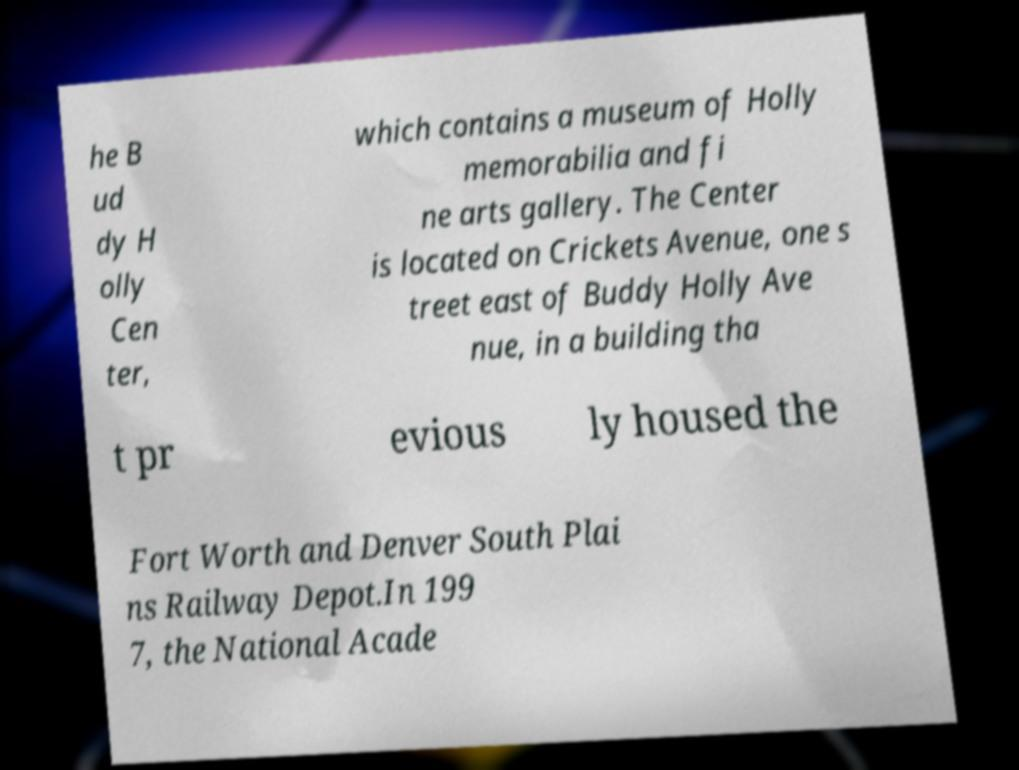Can you read and provide the text displayed in the image?This photo seems to have some interesting text. Can you extract and type it out for me? he B ud dy H olly Cen ter, which contains a museum of Holly memorabilia and fi ne arts gallery. The Center is located on Crickets Avenue, one s treet east of Buddy Holly Ave nue, in a building tha t pr evious ly housed the Fort Worth and Denver South Plai ns Railway Depot.In 199 7, the National Acade 